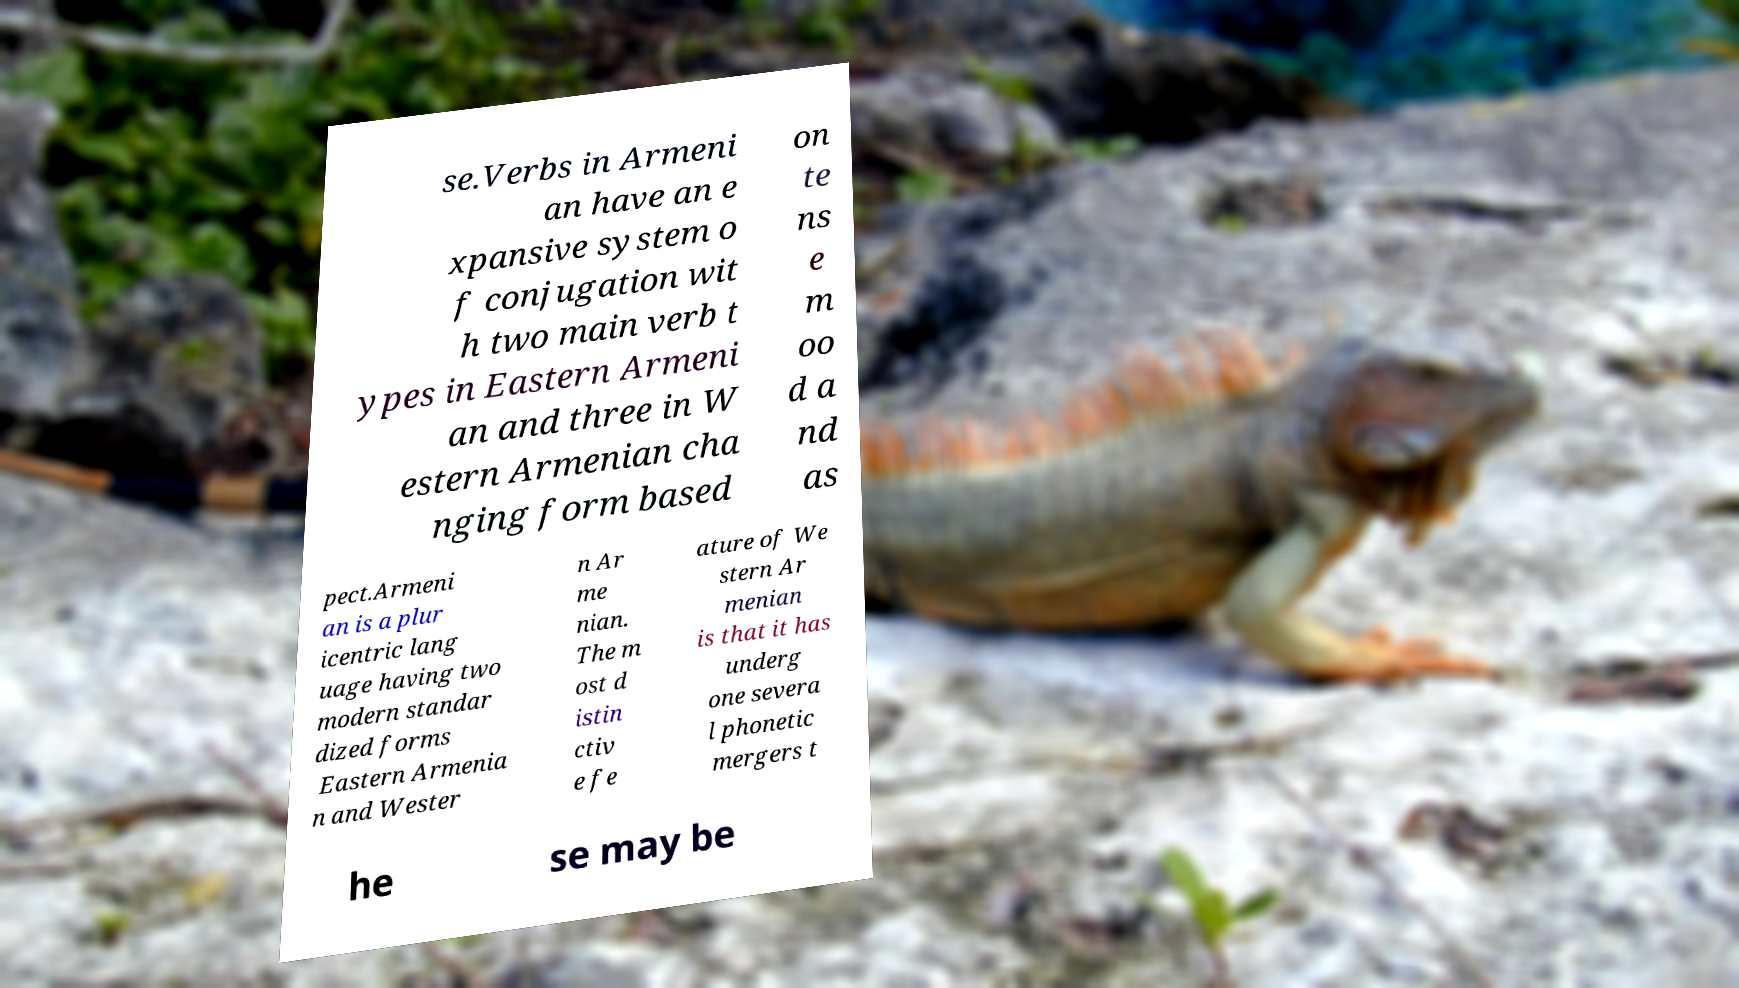Can you read and provide the text displayed in the image?This photo seems to have some interesting text. Can you extract and type it out for me? se.Verbs in Armeni an have an e xpansive system o f conjugation wit h two main verb t ypes in Eastern Armeni an and three in W estern Armenian cha nging form based on te ns e m oo d a nd as pect.Armeni an is a plur icentric lang uage having two modern standar dized forms Eastern Armenia n and Wester n Ar me nian. The m ost d istin ctiv e fe ature of We stern Ar menian is that it has underg one severa l phonetic mergers t he se may be 